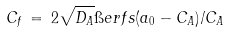<formula> <loc_0><loc_0><loc_500><loc_500>C _ { f } \, = \, 2 \sqrt { D _ { A } } \i e r f s { ( a _ { 0 } - C _ { A } ) / C _ { A } }</formula> 